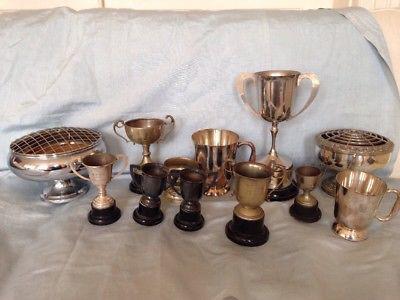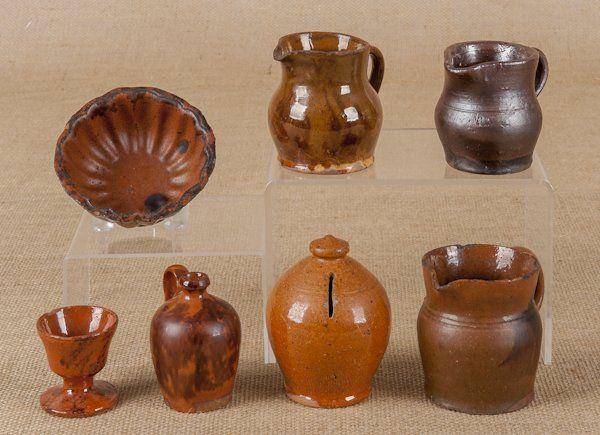The first image is the image on the left, the second image is the image on the right. For the images displayed, is the sentence "Have mugs have coffee inside them in one of the pictures." factually correct? Answer yes or no. No. The first image is the image on the left, the second image is the image on the right. For the images shown, is this caption "The left and right image contains a total of no more than ten cups." true? Answer yes or no. No. 